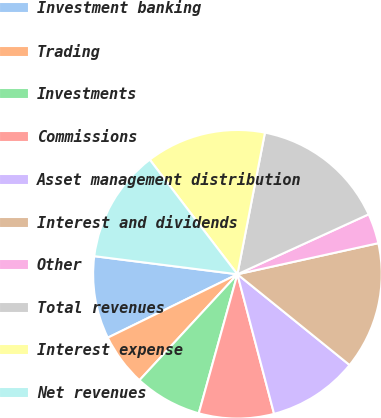Convert chart. <chart><loc_0><loc_0><loc_500><loc_500><pie_chart><fcel>Investment banking<fcel>Trading<fcel>Investments<fcel>Commissions<fcel>Asset management distribution<fcel>Interest and dividends<fcel>Other<fcel>Total revenues<fcel>Interest expense<fcel>Net revenues<nl><fcel>9.24%<fcel>5.88%<fcel>7.56%<fcel>8.4%<fcel>10.08%<fcel>14.28%<fcel>3.36%<fcel>15.12%<fcel>13.44%<fcel>12.6%<nl></chart> 